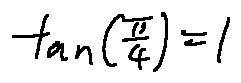Convert formula to latex. <formula><loc_0><loc_0><loc_500><loc_500>\tan ( \frac { \pi } { 4 } ) = 1</formula> 